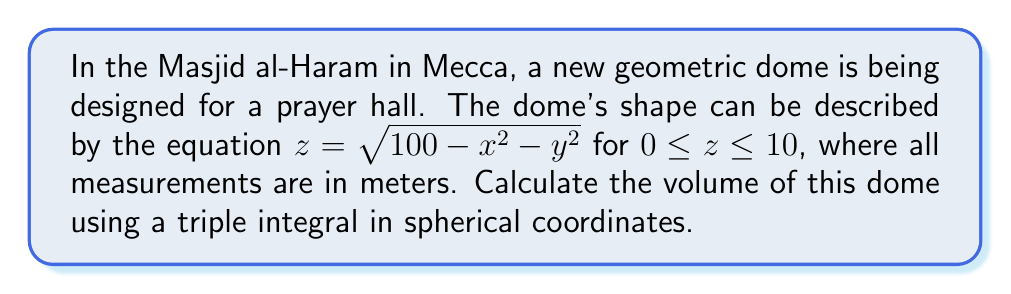Solve this math problem. To solve this problem, we'll follow these steps:

1) First, we need to set up the triple integral in spherical coordinates. The volume of the dome is given by:

   $$V = \iiint_D r^2 \sin\phi \, dr \, d\phi \, d\theta$$

   where $D$ is the domain of integration.

2) In spherical coordinates, we have:
   $x = r \sin\phi \cos\theta$
   $y = r \sin\phi \sin\theta$
   $z = r \cos\phi$

3) The equation of the dome $z = \sqrt{100 - x^2 - y^2}$ in spherical coordinates becomes:
   $r \cos\phi = \sqrt{100 - r^2 \sin^2\phi}$

4) Solving for $r$:
   $r^2 \cos^2\phi = 100 - r^2 \sin^2\phi$
   $r^2 (\cos^2\phi + \sin^2\phi) = 100$
   $r^2 = 100$
   $r = 10$

5) The limits of integration are:
   $0 \leq r \leq 10$
   $0 \leq \phi \leq \frac{\pi}{2}$ (since the dome is in the upper half-space)
   $0 \leq \theta \leq 2\pi$

6) Now we can set up the triple integral:

   $$V = \int_0^{2\pi} \int_0^{\frac{\pi}{2}} \int_0^{10} r^2 \sin\phi \, dr \, d\phi \, d\theta$$

7) Integrate with respect to $r$:
   $$V = \int_0^{2\pi} \int_0^{\frac{\pi}{2}} [\frac{1}{3}r^3]_0^{10} \sin\phi \, d\phi \, d\theta$$
   $$V = \frac{1000}{3} \int_0^{2\pi} \int_0^{\frac{\pi}{2}} \sin\phi \, d\phi \, d\theta$$

8) Integrate with respect to $\phi$:
   $$V = \frac{1000}{3} \int_0^{2\pi} [-\cos\phi]_0^{\frac{\pi}{2}} \, d\theta$$
   $$V = \frac{1000}{3} \int_0^{2\pi} 1 \, d\theta$$

9) Finally, integrate with respect to $\theta$:
   $$V = \frac{1000}{3} [2\pi] = \frac{2000\pi}{3}$$

Therefore, the volume of the dome is $\frac{2000\pi}{3}$ cubic meters.
Answer: $\frac{2000\pi}{3}$ m³ 